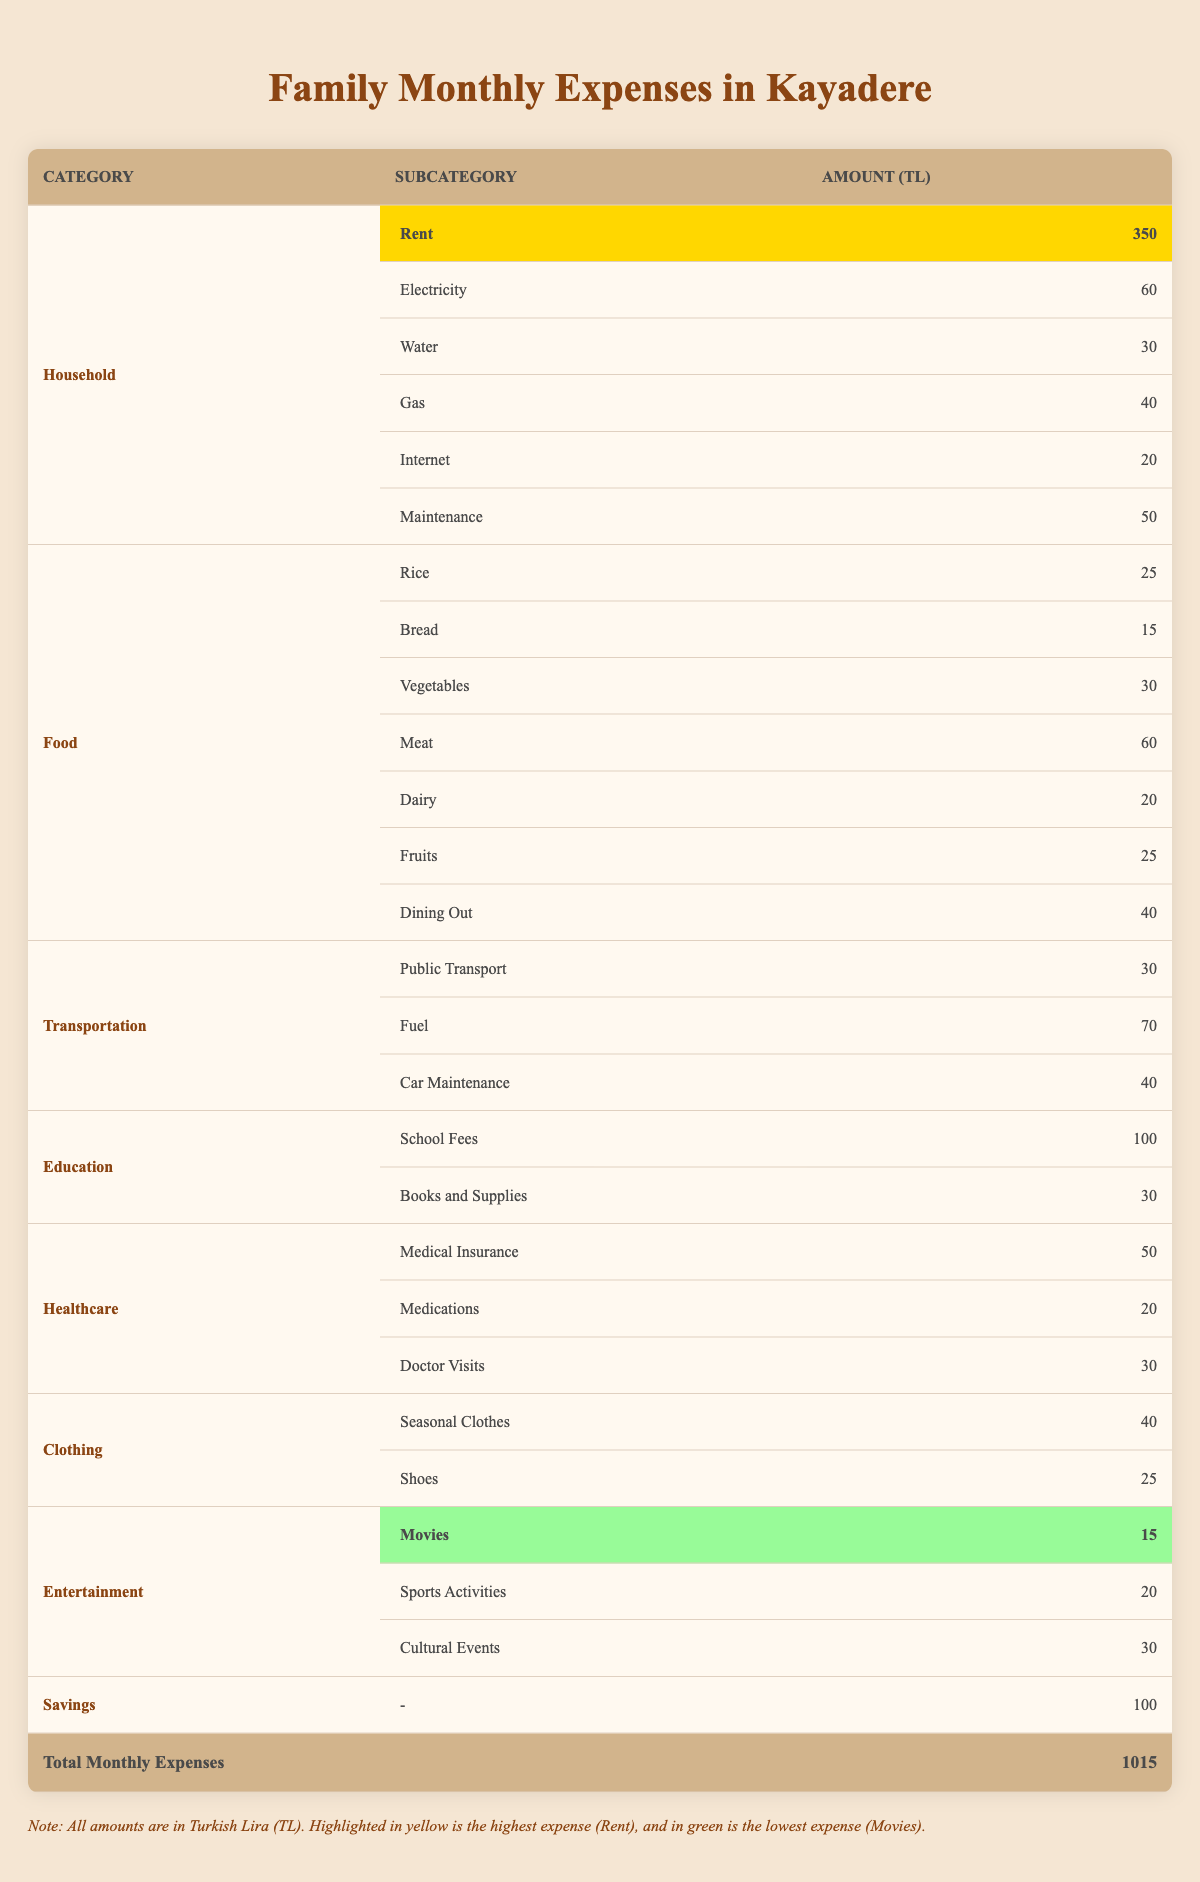What is the highest monthly expense? The table shows various expenses, and the highlighted value for the highest expense is found under the Household category, specifically for Rent, which is 350 TL.
Answer: 350 TL What is the lowest monthly expense? The table highlights the lowest expense in the Entertainment category for Movies, which amounts to 15 TL.
Answer: 15 TL How much is spent on Food in total? To find the total Food expenses, I add all the related subcategories: Rice (25) + Bread (15) + Vegetables (30) + Meat (60) + Dairy (20) + Fruits (25) + Dining Out (40) = 205 TL.
Answer: 205 TL What is the combined Healthcare expense? I sum up the expenses under Healthcare: Medical Insurance (50) + Medications (20) + Doctor Visits (30) = 100 TL.
Answer: 100 TL Is the amount spent on Healthcare greater than that spent on Education? The Healthcare total is 100 TL, while Education totals 130 TL (School Fees 100 + Books 30). Since 100 is less than 130, the statement is false.
Answer: No What is the total amount spent on Transportation? The Transportation expenses include Public Transport (30) + Fuel (70) + Car Maintenance (40), resulting in a total of 140 TL.
Answer: 140 TL What are the total Discretionary Expenses? Discretionary expenses include Dining Out (40) and Entertainment (65). When added, they total 105 TL.
Answer: 105 TL If I save 100 TL, what part of the total monthly expenses is it? To find the percentage of savings relative to total expenses, I divide Savings (100) by Total Monthly Expenses (1015) and multiply by 100: (100/1015) * 100 ≈ 9.85%.
Answer: 9.85% What is the average cost of Clothing? The total Clothing expense is Seasonal Clothes (40) + Shoes (25) = 65 TL. Divided by 2 different clothing subcategories gives 65/2 = 32.5 TL as the average cost.
Answer: 32.5 TL Which category has a higher total, Healthcare or Food? Healthcare sums to 100 TL, while Food totals 205 TL. Comparing these two totals indicates that Food is higher than Healthcare.
Answer: Food is higher 